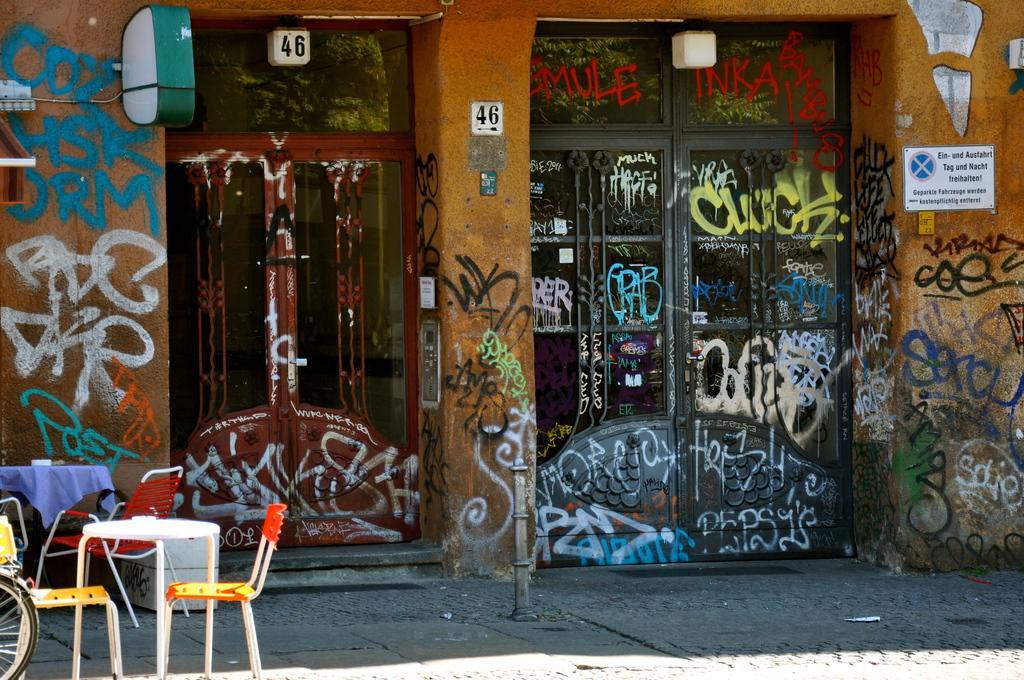In one or two sentences, can you explain what this image depicts? Here we can see a door, and at side here is the wall and paintings on it, and here is the table and chairs on the floor. 